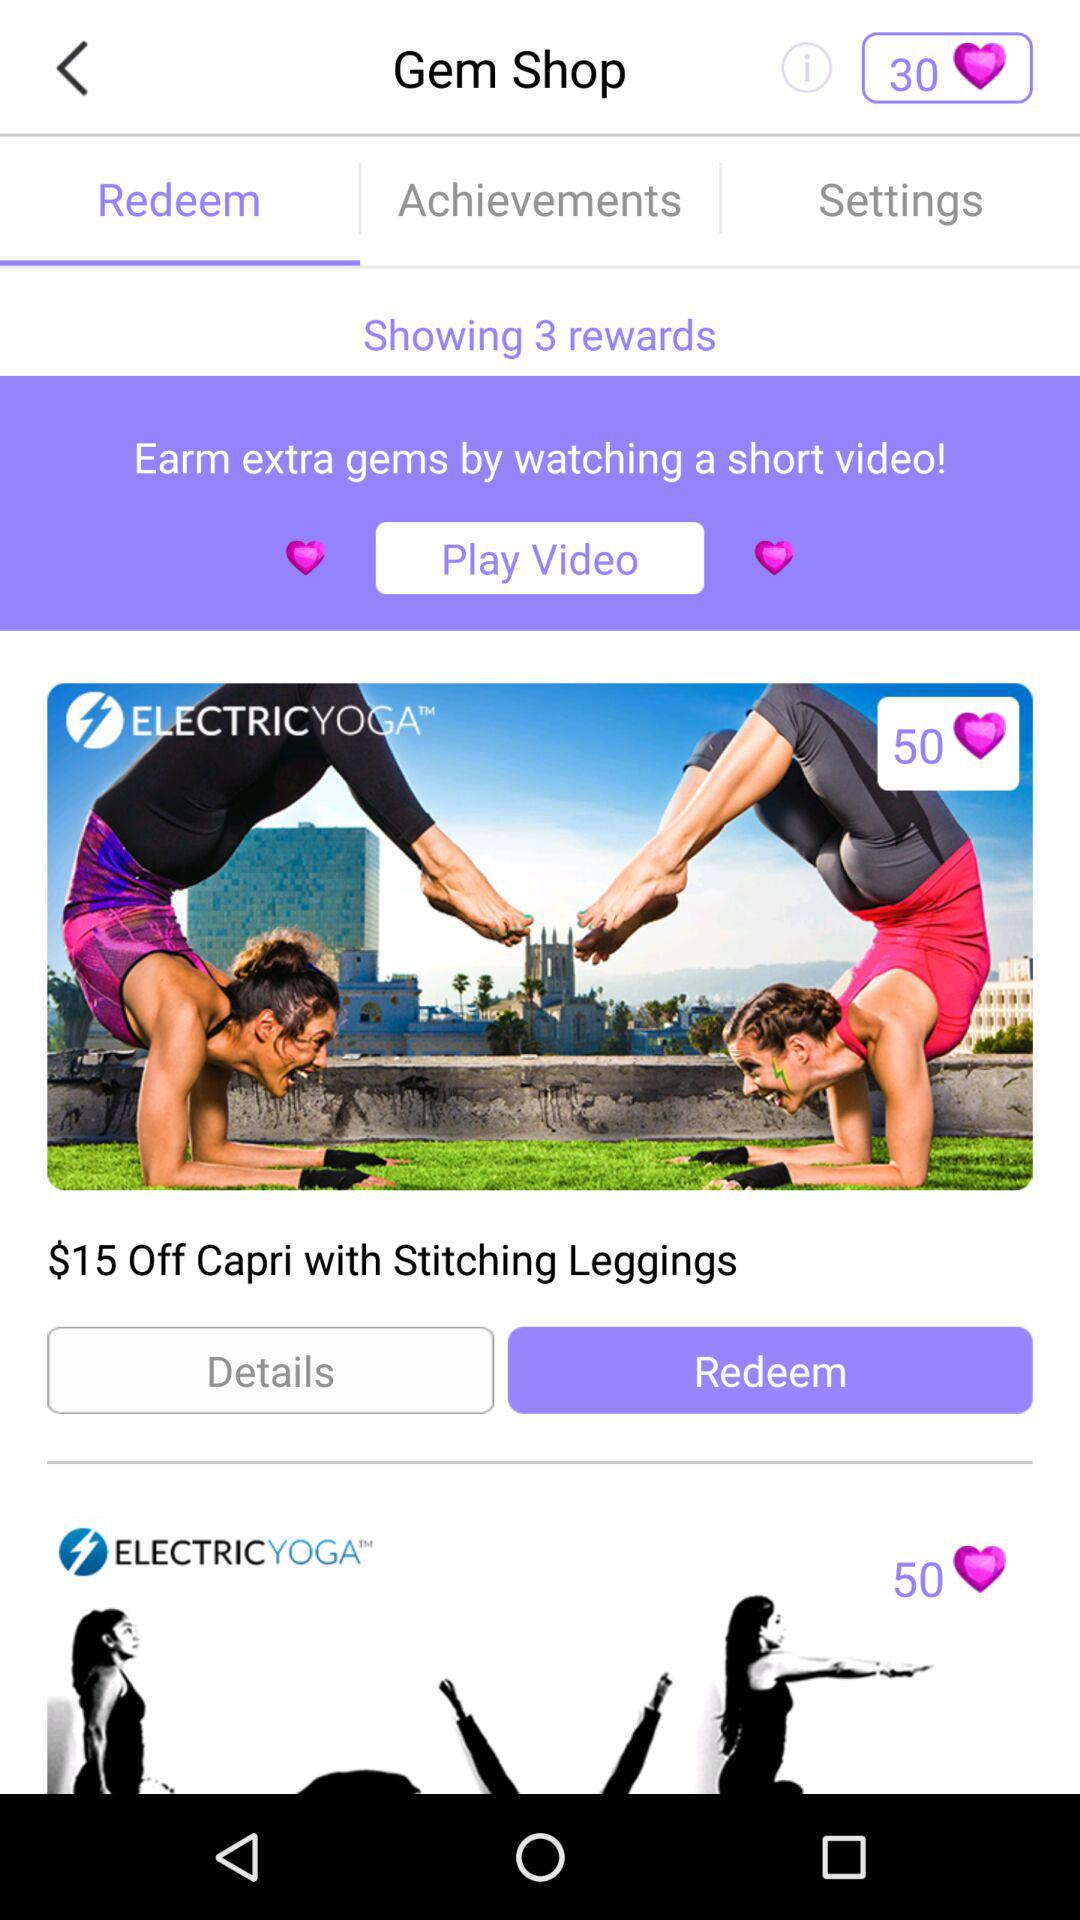How many gems are in the balance? There are 30 gems in the balance. 